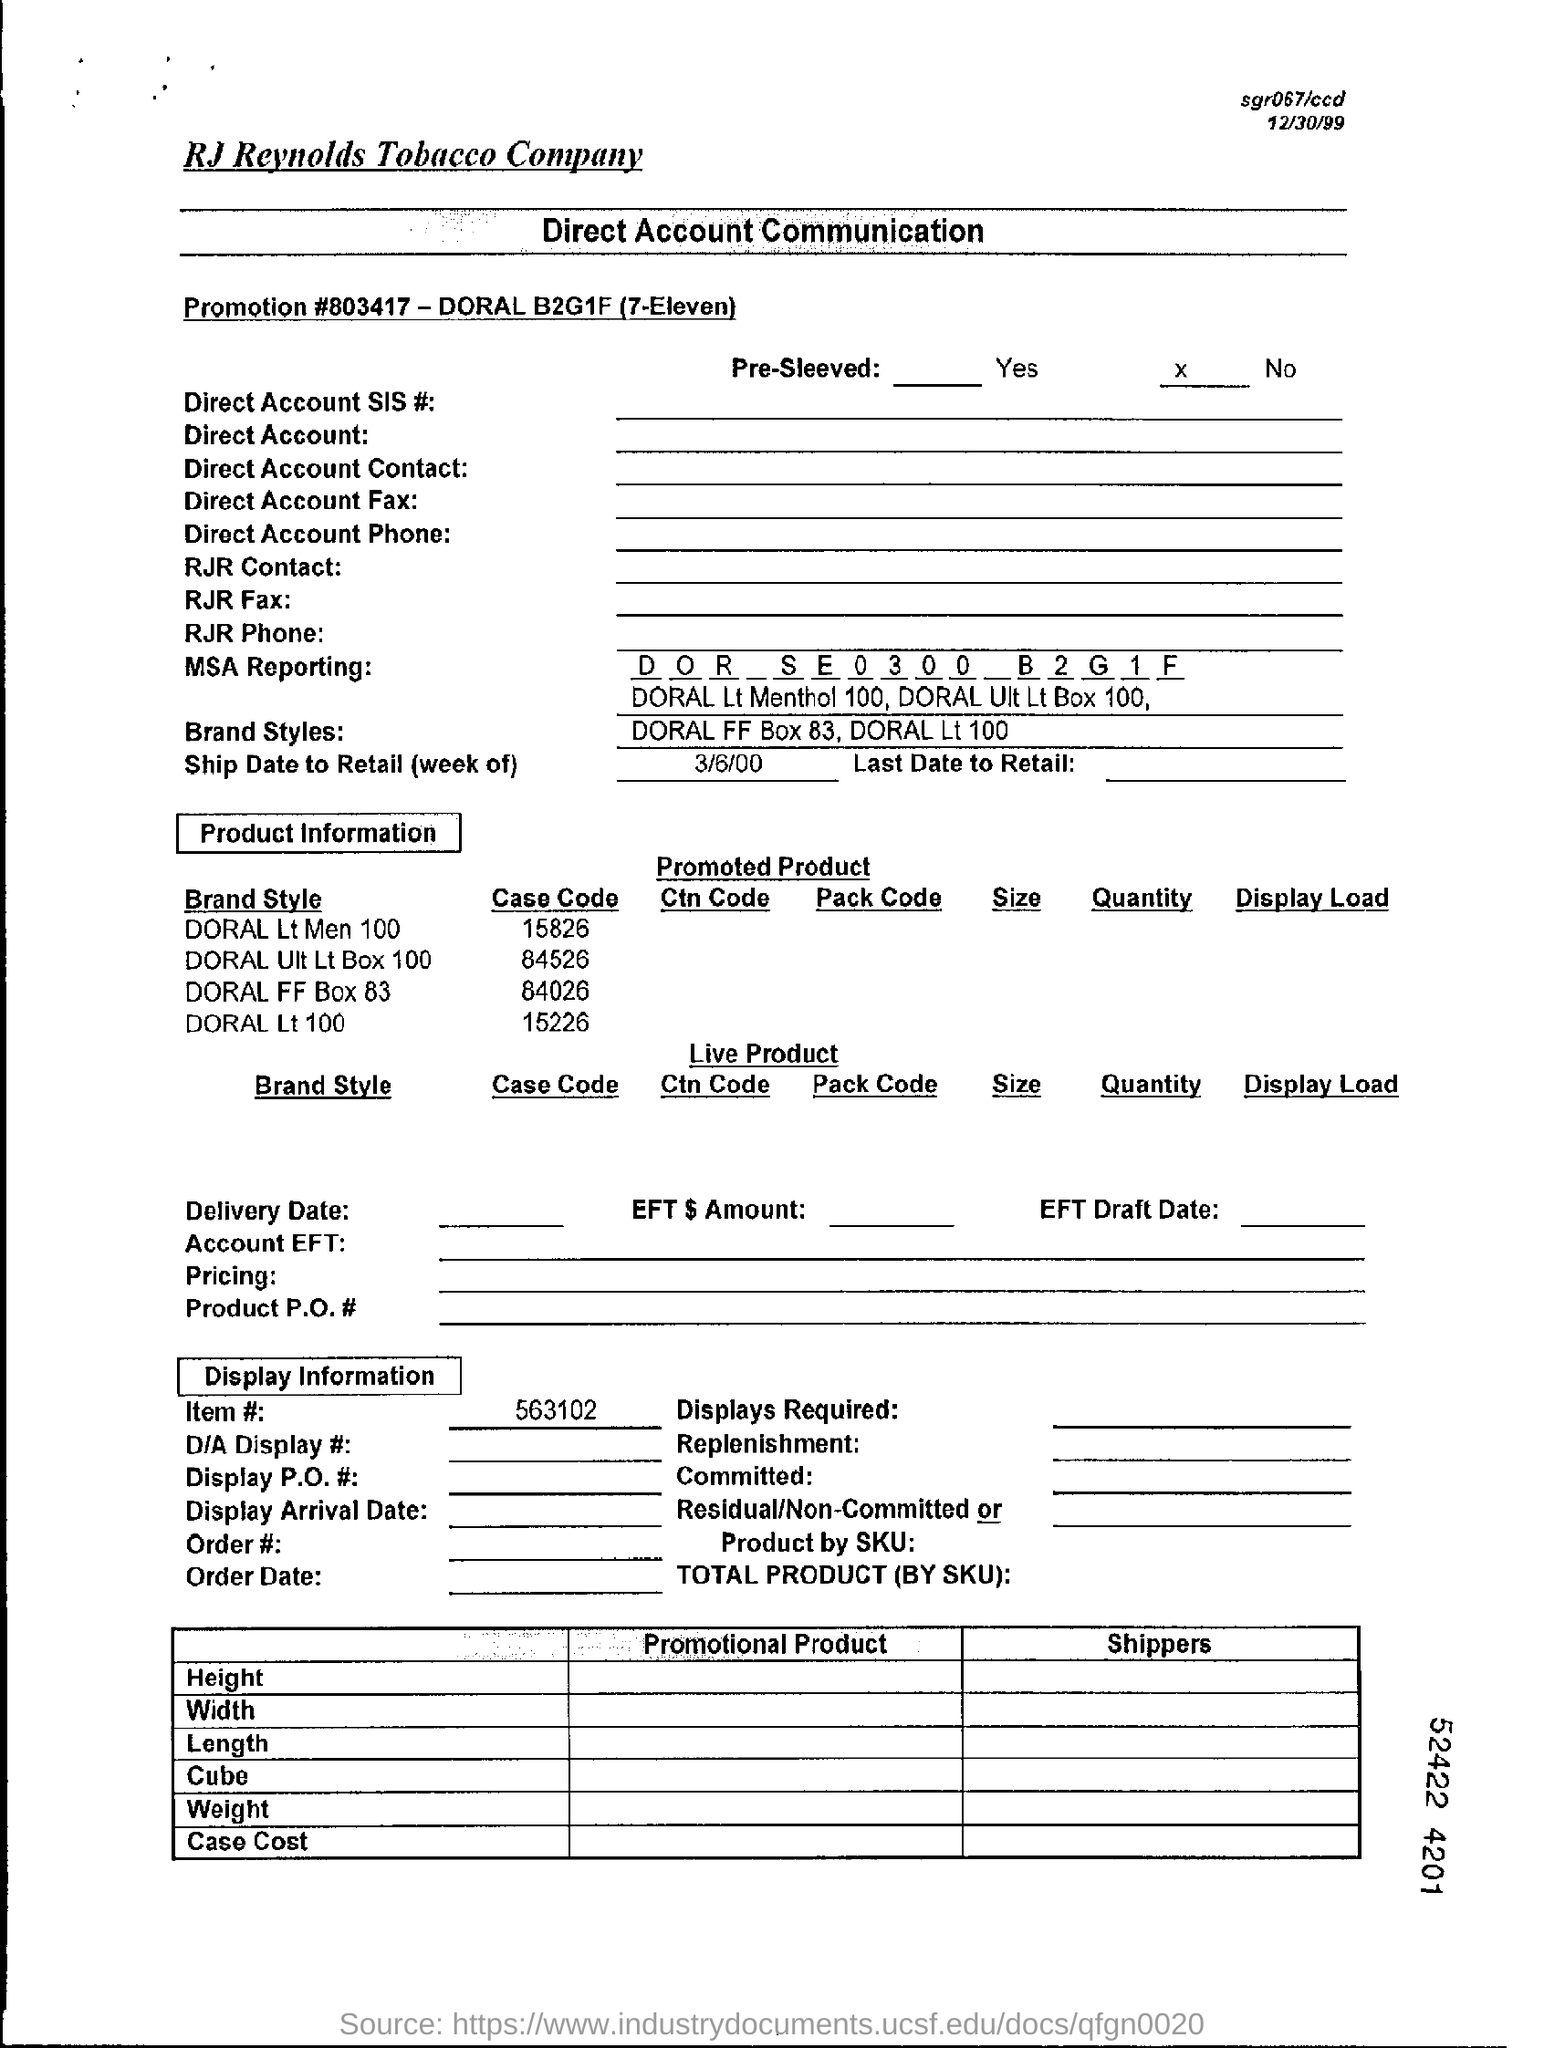Draw attention to some important aspects in this diagram. The item number mentioned in the document is 563102... The promotion number mentioned in the document is 803417... The ship date to retail is March 6, 2000. 